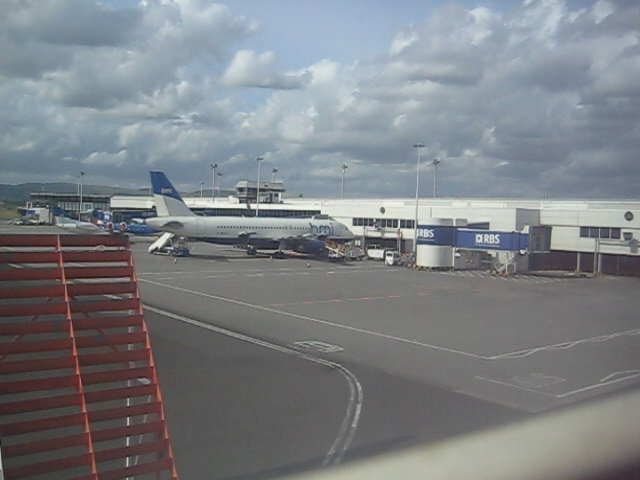Describe the objects in this image and their specific colors. I can see airplane in darkgray, gray, lightgray, and black tones and car in darkgray, gray, and black tones in this image. 